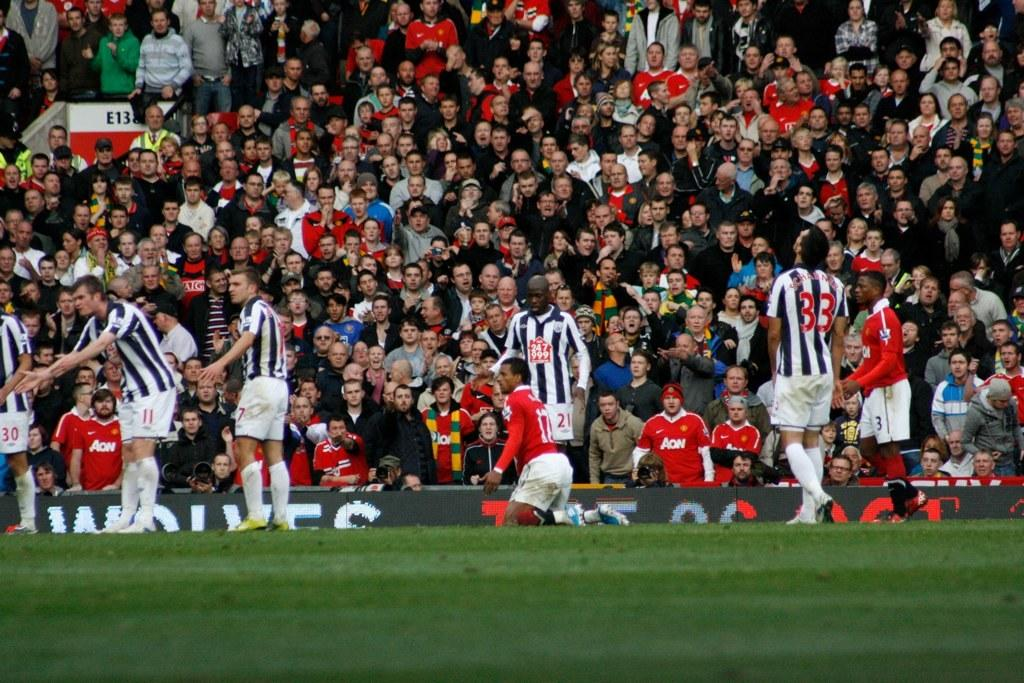What is happening in the ground in the image? There are players standing in the ground. What can be seen in the background of the image? There are other people standing and sitting in the stadium. What are the people in the stadium doing? The people in the stadium are watching the players. What type of wall can be seen in the image? There is no wall present in the image; it features a stadium with players and spectators. What list is being referred to in the image? There is no list mentioned or visible in the image. 